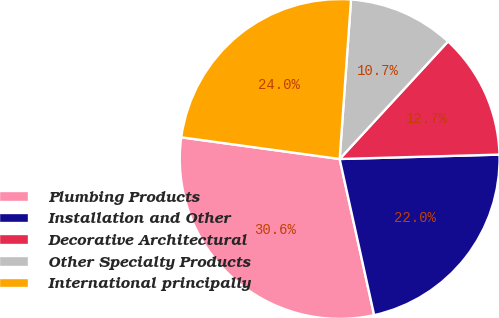<chart> <loc_0><loc_0><loc_500><loc_500><pie_chart><fcel>Plumbing Products<fcel>Installation and Other<fcel>Decorative Architectural<fcel>Other Specialty Products<fcel>International principally<nl><fcel>30.63%<fcel>21.98%<fcel>12.71%<fcel>10.72%<fcel>23.97%<nl></chart> 